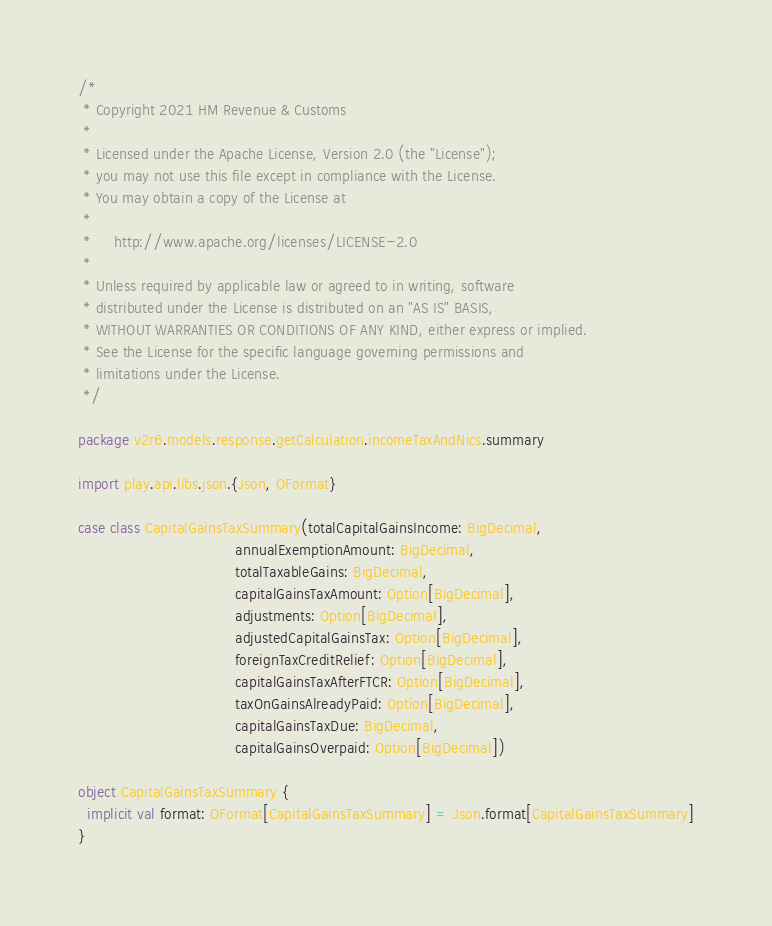Convert code to text. <code><loc_0><loc_0><loc_500><loc_500><_Scala_>/*
 * Copyright 2021 HM Revenue & Customs
 *
 * Licensed under the Apache License, Version 2.0 (the "License");
 * you may not use this file except in compliance with the License.
 * You may obtain a copy of the License at
 *
 *     http://www.apache.org/licenses/LICENSE-2.0
 *
 * Unless required by applicable law or agreed to in writing, software
 * distributed under the License is distributed on an "AS IS" BASIS,
 * WITHOUT WARRANTIES OR CONDITIONS OF ANY KIND, either express or implied.
 * See the License for the specific language governing permissions and
 * limitations under the License.
 */

package v2r6.models.response.getCalculation.incomeTaxAndNics.summary

import play.api.libs.json.{Json, OFormat}

case class CapitalGainsTaxSummary(totalCapitalGainsIncome: BigDecimal,
                                  annualExemptionAmount: BigDecimal,
                                  totalTaxableGains: BigDecimal,
                                  capitalGainsTaxAmount: Option[BigDecimal],
                                  adjustments: Option[BigDecimal],
                                  adjustedCapitalGainsTax: Option[BigDecimal],
                                  foreignTaxCreditRelief: Option[BigDecimal],
                                  capitalGainsTaxAfterFTCR: Option[BigDecimal],
                                  taxOnGainsAlreadyPaid: Option[BigDecimal],
                                  capitalGainsTaxDue: BigDecimal,
                                  capitalGainsOverpaid: Option[BigDecimal])

object CapitalGainsTaxSummary {
  implicit val format: OFormat[CapitalGainsTaxSummary] = Json.format[CapitalGainsTaxSummary]
}
</code> 